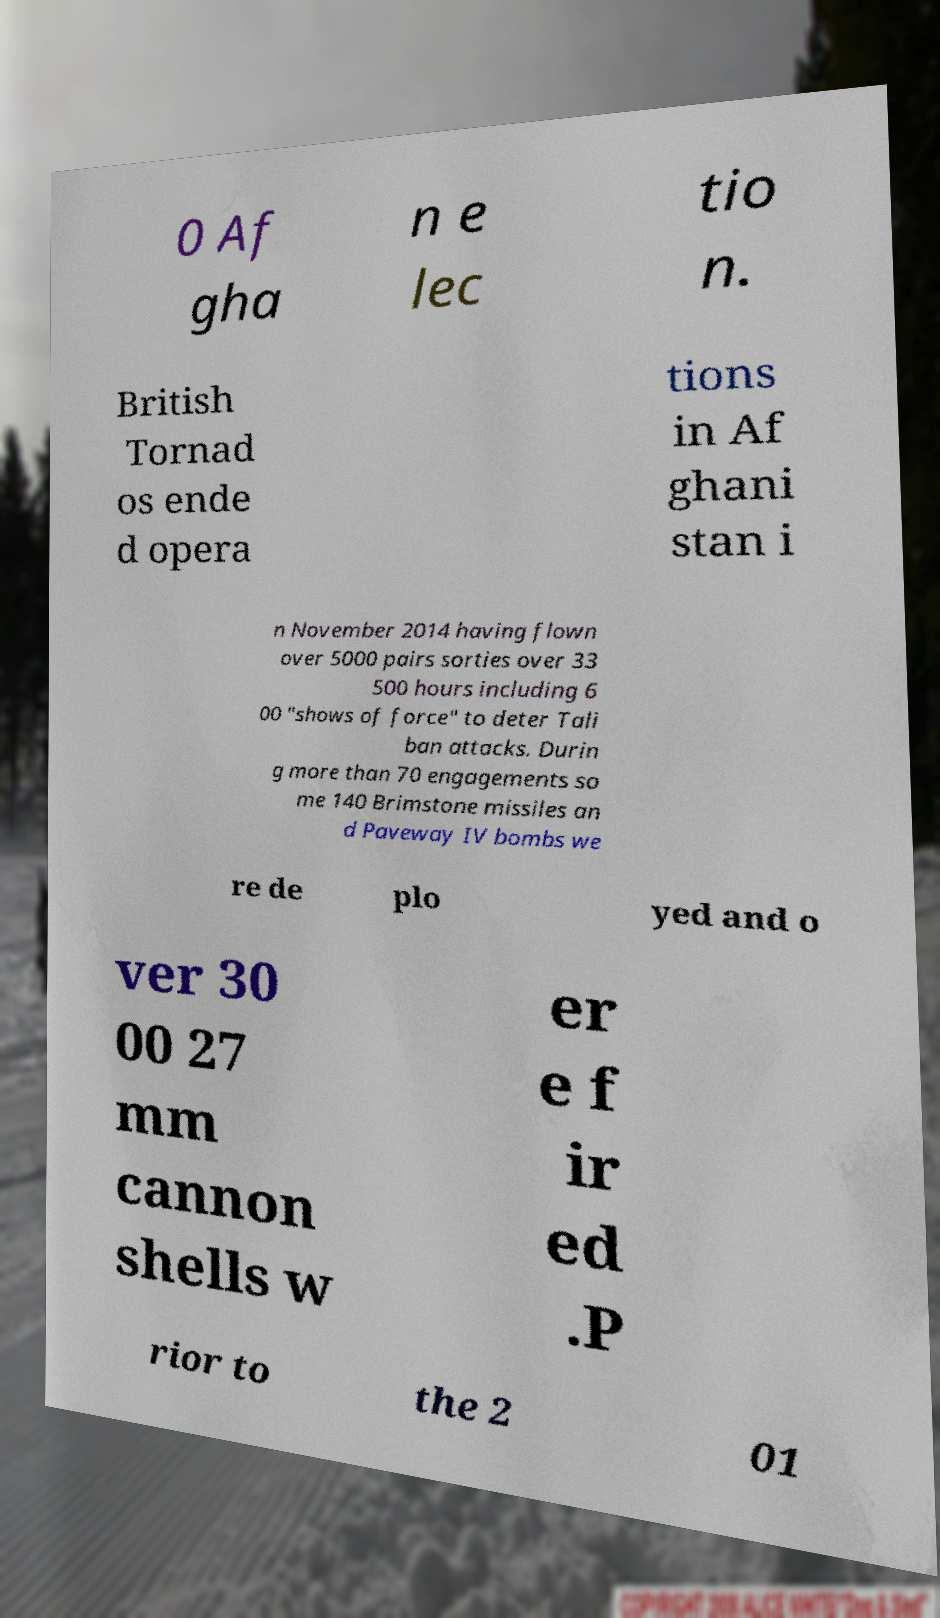Can you read and provide the text displayed in the image?This photo seems to have some interesting text. Can you extract and type it out for me? 0 Af gha n e lec tio n. British Tornad os ende d opera tions in Af ghani stan i n November 2014 having flown over 5000 pairs sorties over 33 500 hours including 6 00 "shows of force" to deter Tali ban attacks. Durin g more than 70 engagements so me 140 Brimstone missiles an d Paveway IV bombs we re de plo yed and o ver 30 00 27 mm cannon shells w er e f ir ed .P rior to the 2 01 